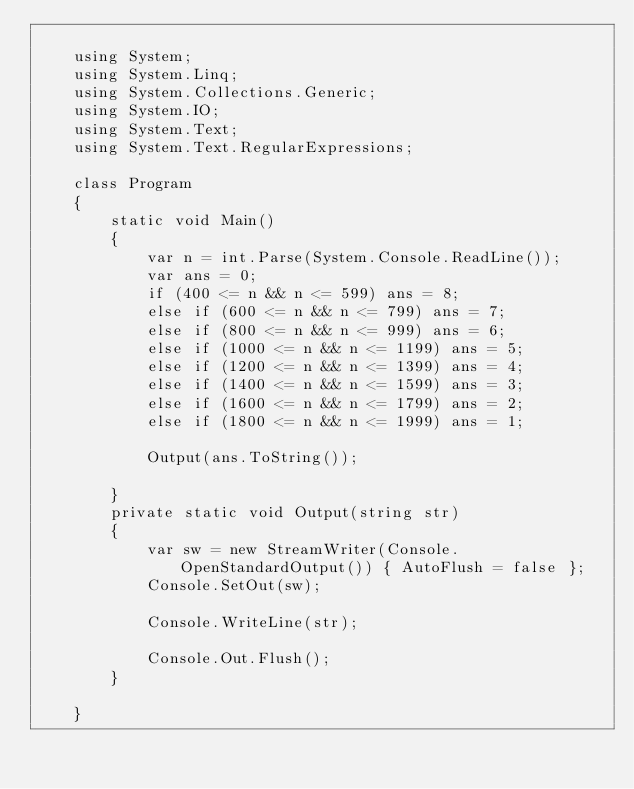Convert code to text. <code><loc_0><loc_0><loc_500><loc_500><_C#_>
    using System;
    using System.Linq;
    using System.Collections.Generic;
    using System.IO;
    using System.Text;
    using System.Text.RegularExpressions;

    class Program
    {
        static void Main()
        {
            var n = int.Parse(System.Console.ReadLine());
            var ans = 0;
            if (400 <= n && n <= 599) ans = 8;
            else if (600 <= n && n <= 799) ans = 7;
            else if (800 <= n && n <= 999) ans = 6;
            else if (1000 <= n && n <= 1199) ans = 5;
            else if (1200 <= n && n <= 1399) ans = 4;
            else if (1400 <= n && n <= 1599) ans = 3;
            else if (1600 <= n && n <= 1799) ans = 2;
            else if (1800 <= n && n <= 1999) ans = 1;

            Output(ans.ToString());

        }
        private static void Output(string str)
        {
            var sw = new StreamWriter(Console.OpenStandardOutput()) { AutoFlush = false };
            Console.SetOut(sw);

            Console.WriteLine(str);

            Console.Out.Flush();
        }

    }</code> 